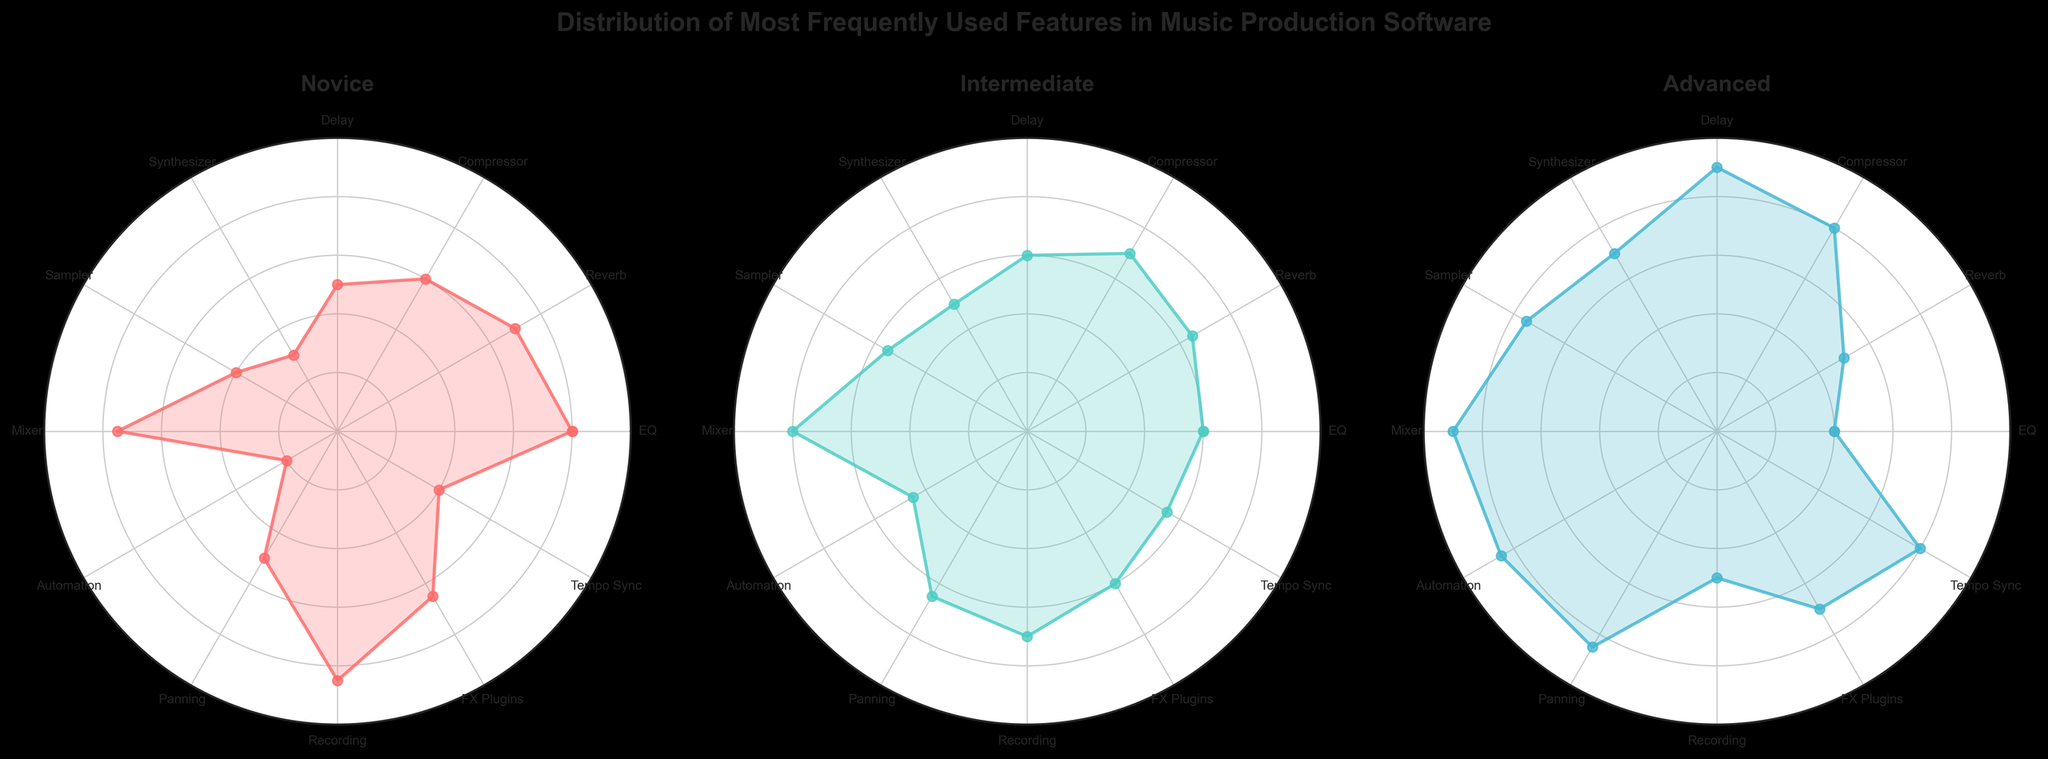What feature is most frequently used by novice users? To find the answer, look at the plot for novice users and compare the values for each feature. The highest point is at "Recording" with a value of 85.
Answer: Recording Which user proficiency level uses "Automation" the most? Compare the "Automation" values across all three plots. The advanced users have the highest value at 85.
Answer: Advanced What's the average usage percentage of the "Compressor" across all proficiency levels? Add the values of "Compressor" for Novice (60), Intermediate (70), and Advanced (80) and divide by 3: (60+70+80)/3 = 70.
Answer: 70 Which feature has the largest difference in usage between novice and advanced users? Calculate the difference between novice and advanced users for each feature, and find the maximum difference. "Automation" has the largest difference with a value of 65 (85-20 = 65).
Answer: Automation What is the range of usage percentages for intermediate users for the feature "Delay"? Identify the "Delay" values for novice (50), intermediate (60), and advanced (90) users. The intermediate value is 60. The range is the difference between the maximum and minimum percentage levels on the intermediate plot, which extends from 0 to 80.
Answer: 60 Which features have equal usage by both novice and intermediate users? Check for features with identical values in both novice and intermediate plots. There are no features where the usage is exactly the same for both groups.
Answer: None What is the least used feature by advanced users? Look at the lowest point on the advanced plot. The lowest value is for "EQ" with a value of 40.
Answer: EQ How much higher is the use of "Mixer" by advanced users compared to novice users? Find the "Mixer" values for novice (75) and advanced (90) users, then subtract the novice value from the advanced value: 90 - 75 = 15.
Answer: 15 Which feature shows a consistent increase in usage from novice to advanced users? Look for features that increase in value from novice to intermediate to advanced. "Delay" increases from 50 (Novice) to 60 (Intermediate) to 90 (Advanced).
Answer: Delay 